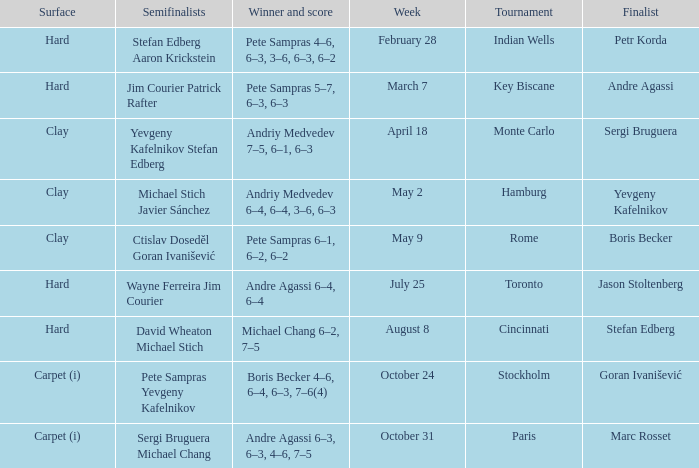Who was the semifinalist for the key biscane tournament? Jim Courier Patrick Rafter. 